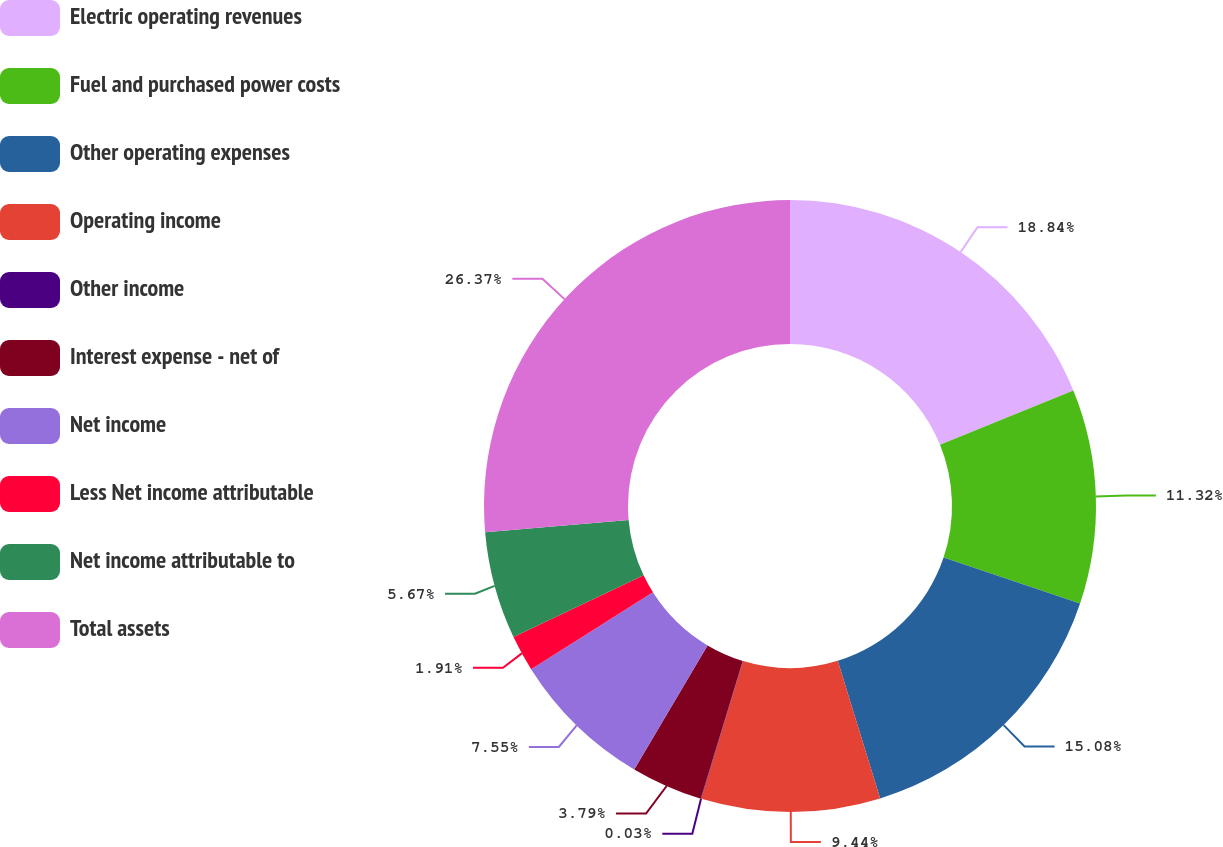Convert chart to OTSL. <chart><loc_0><loc_0><loc_500><loc_500><pie_chart><fcel>Electric operating revenues<fcel>Fuel and purchased power costs<fcel>Other operating expenses<fcel>Operating income<fcel>Other income<fcel>Interest expense - net of<fcel>Net income<fcel>Less Net income attributable<fcel>Net income attributable to<fcel>Total assets<nl><fcel>18.84%<fcel>11.32%<fcel>15.08%<fcel>9.44%<fcel>0.03%<fcel>3.79%<fcel>7.55%<fcel>1.91%<fcel>5.67%<fcel>26.37%<nl></chart> 